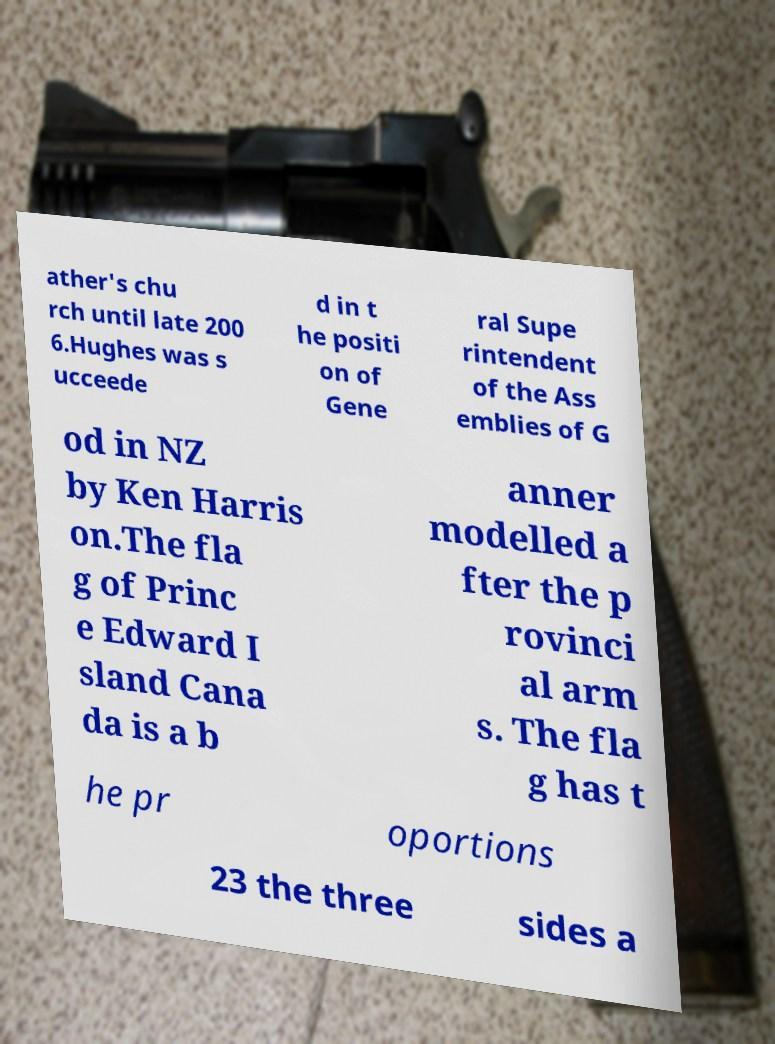Could you assist in decoding the text presented in this image and type it out clearly? ather's chu rch until late 200 6.Hughes was s ucceede d in t he positi on of Gene ral Supe rintendent of the Ass emblies of G od in NZ by Ken Harris on.The fla g of Princ e Edward I sland Cana da is a b anner modelled a fter the p rovinci al arm s. The fla g has t he pr oportions 23 the three sides a 